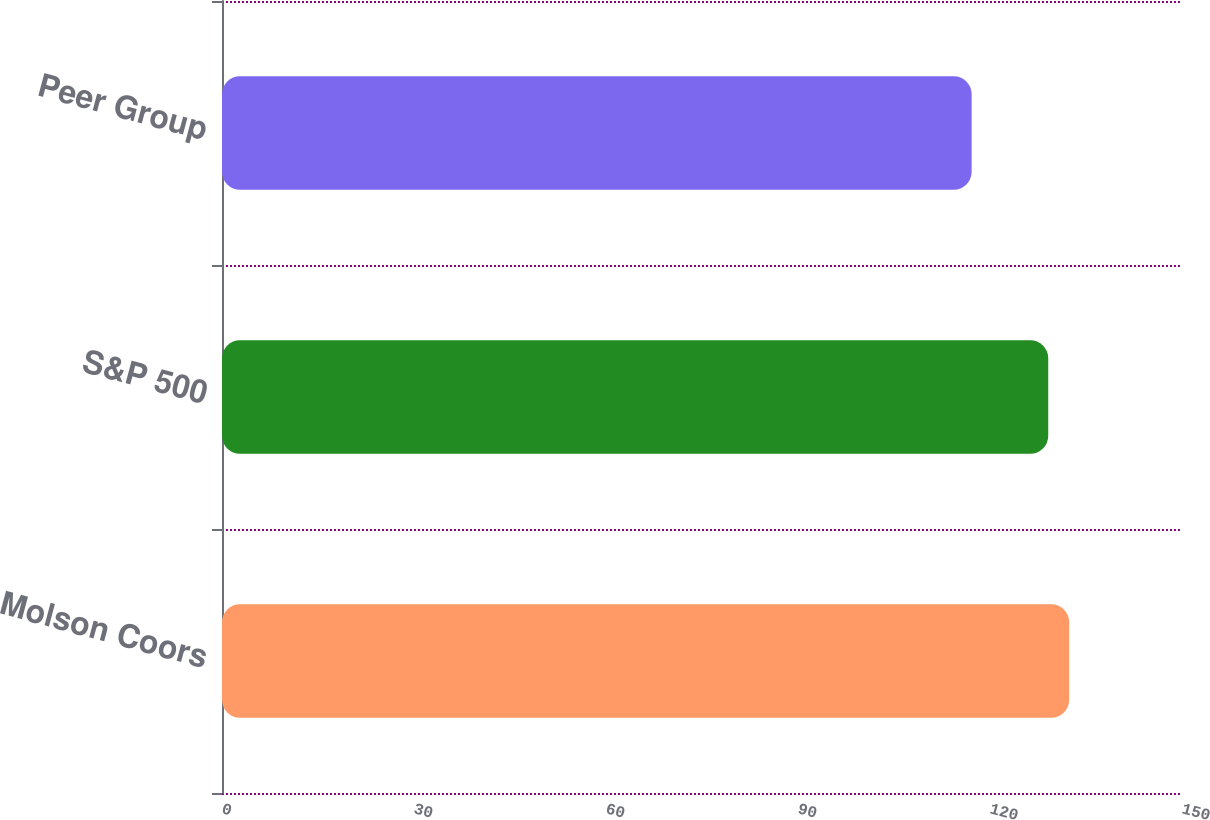<chart> <loc_0><loc_0><loc_500><loc_500><bar_chart><fcel>Molson Coors<fcel>S&P 500<fcel>Peer Group<nl><fcel>132.37<fcel>129.1<fcel>117.13<nl></chart> 